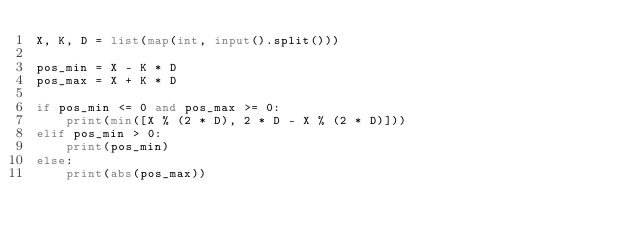Convert code to text. <code><loc_0><loc_0><loc_500><loc_500><_Python_>X, K, D = list(map(int, input().split()))

pos_min = X - K * D
pos_max = X + K * D

if pos_min <= 0 and pos_max >= 0:
    print(min([X % (2 * D), 2 * D - X % (2 * D)]))
elif pos_min > 0:
    print(pos_min)
else:
    print(abs(pos_max))</code> 